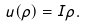Convert formula to latex. <formula><loc_0><loc_0><loc_500><loc_500>u ( \rho ) = I \rho .</formula> 